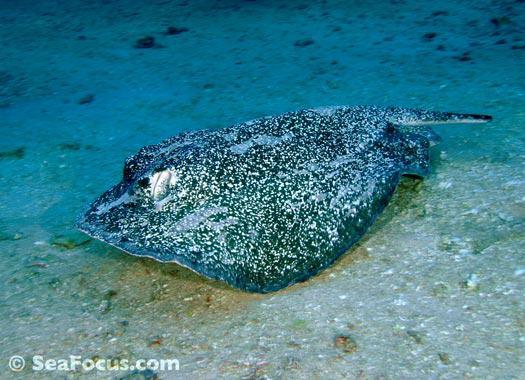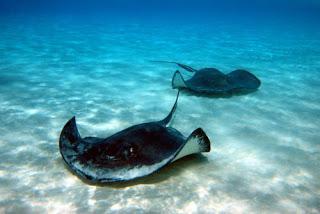The first image is the image on the left, the second image is the image on the right. For the images shown, is this caption "Hands are extended toward a stingray in at least one image, and an image shows at least two people in the water with a stingray." true? Answer yes or no. No. The first image is the image on the left, the second image is the image on the right. Analyze the images presented: Is the assertion "there are 3 stingrays in the image pair" valid? Answer yes or no. Yes. 